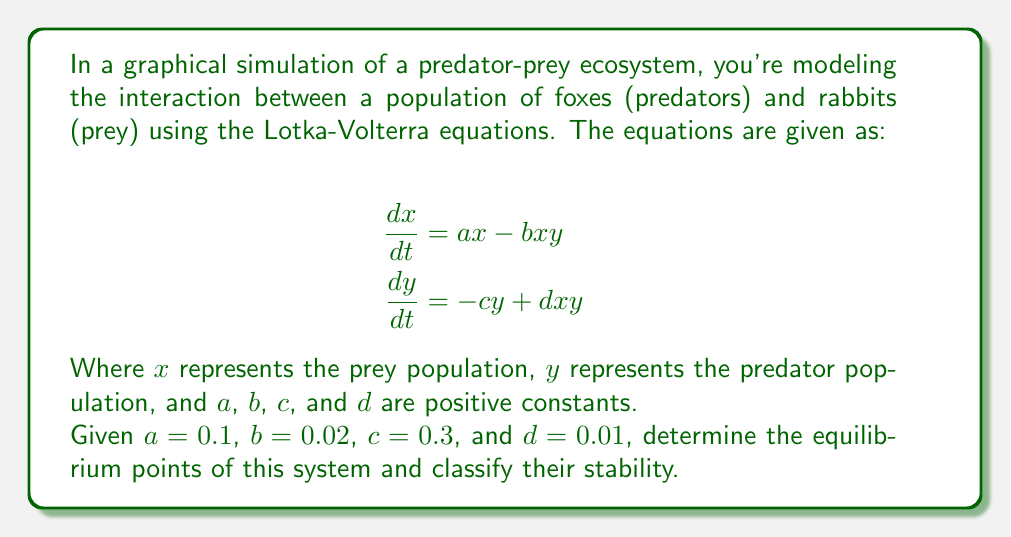Teach me how to tackle this problem. To solve this problem, we'll follow these steps:

1. Find the equilibrium points by setting both equations to zero and solving for $x$ and $y$.
2. Analyze the stability of each equilibrium point using the Jacobian matrix.

Step 1: Finding equilibrium points

Set both equations to zero:

$$0 = ax - bxy$$
$$0 = -cy + dxy$$

From the second equation:
$$cy = dxy$$
$$y(c - dx) = 0$$

This gives us two cases:
a) $y = 0$, or
b) $c - dx = 0$ $\Rightarrow$ $x = \frac{c}{d}$

Case a: If $y = 0$, from the first equation:
$$0 = ax - b(0)x = ax$$
This implies either $x = 0$ or $a = 0$. Since $a \neq 0$, we have the equilibrium point $(0, 0)$.

Case b: If $x = \frac{c}{d}$, substitute this into the first equation:
$$0 = a(\frac{c}{d}) - b(\frac{c}{d})y$$
$$\frac{ac}{d} = b(\frac{c}{d})y$$
$$y = \frac{a}{b}$$

Therefore, the second equilibrium point is $(\frac{c}{d}, \frac{a}{b})$.

Step 2: Analyzing stability

To analyze stability, we need to compute the Jacobian matrix:

$$J = \begin{bmatrix}
\frac{\partial}{\partial x}(ax - bxy) & \frac{\partial}{\partial y}(ax - bxy) \\
\frac{\partial}{\partial x}(-cy + dxy) & \frac{\partial}{\partial y}(-cy + dxy)
\end{bmatrix}
= \begin{bmatrix}
a - by & -bx \\
dy & -c + dx
\end{bmatrix}$$

For the equilibrium point $(0, 0)$:

$$J_{(0,0)} = \begin{bmatrix}
a & 0 \\
0 & -c
\end{bmatrix}$$

The eigenvalues are $\lambda_1 = a > 0$ and $\lambda_2 = -c < 0$. Since one eigenvalue is positive and one is negative, $(0, 0)$ is a saddle point and thus unstable.

For the equilibrium point $(\frac{c}{d}, \frac{a}{b})$:

$$J_{(\frac{c}{d}, \frac{a}{b})} = \begin{bmatrix}
0 & -b(\frac{c}{d}) \\
d(\frac{a}{b}) & 0
\end{bmatrix}$$

The eigenvalues are $\lambda_{1,2} = \pm i\sqrt{ac}$. Since these are pure imaginary eigenvalues, this equilibrium point is a center and is neutrally stable.

Substituting the given values:
$(\frac{c}{d}, \frac{a}{b}) = (\frac{0.3}{0.01}, \frac{0.1}{0.02}) = (30, 5)$
Answer: The system has two equilibrium points:
1. $(0, 0)$, which is a saddle point (unstable)
2. $(30, 5)$, which is a center (neutrally stable) 